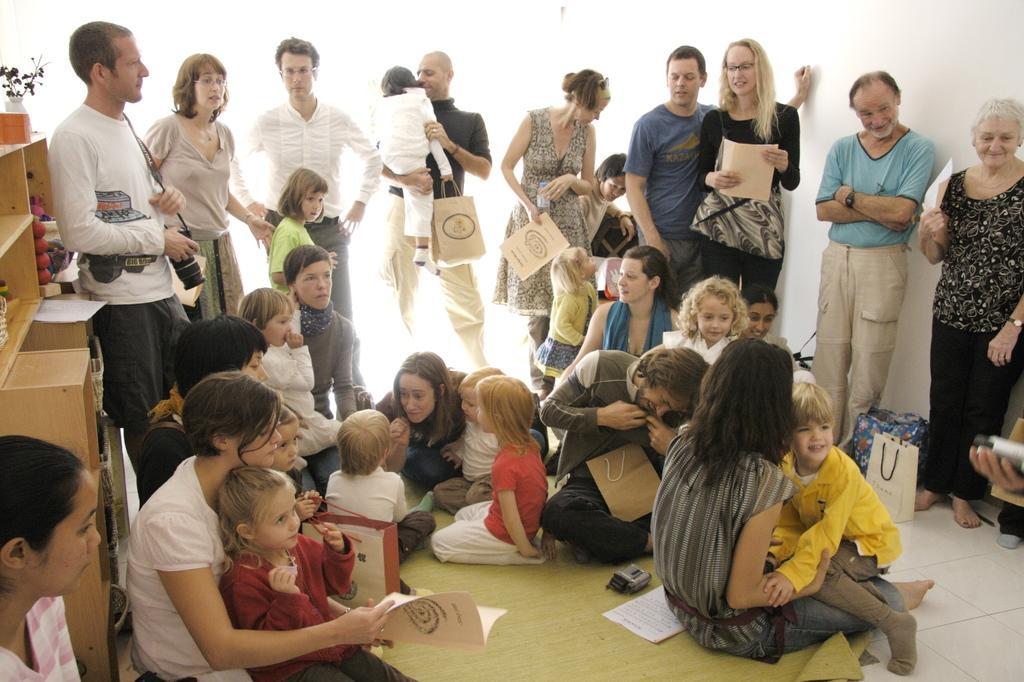Describe this image in one or two sentences. This picture is clicked inside. In the center we can see the group of people sitting and there are some objects placed on the ground. On the left corner there is a wooden cabinet containing a house plant and some other objects. In the background there is a wall and group of people holding some objects and standing on the ground. 